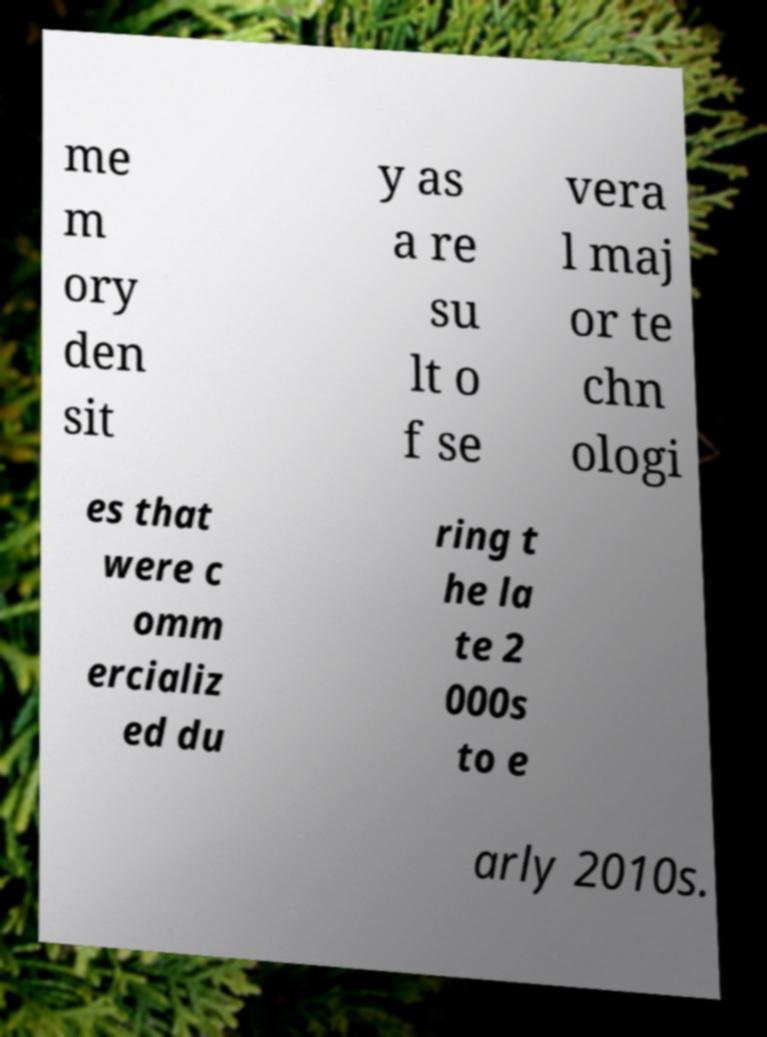Can you read and provide the text displayed in the image?This photo seems to have some interesting text. Can you extract and type it out for me? me m ory den sit y as a re su lt o f se vera l maj or te chn ologi es that were c omm ercializ ed du ring t he la te 2 000s to e arly 2010s. 